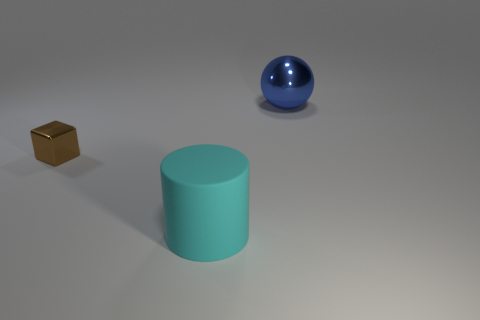How might the lighting in the scene affect the appearance of these objects? The lighting in the scene appears to be soft and diffuse, coming from above. This type of lighting minimizes harsh shadows and allows the inherent colors and textures of the objects to be seen clearly. The metallic cube reflects the light with a subtle highlight, while the matte cylinder absorbs more light, appearing flatter. The sphere with its glossy surface has a bright highlight that shows off its reflective nature and curved surface. 